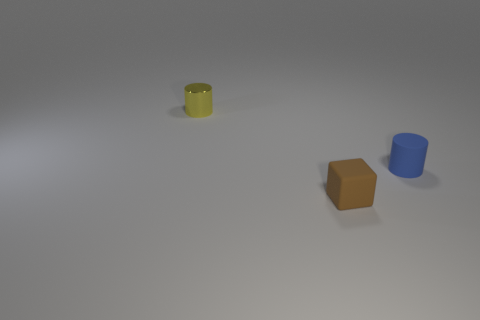Add 1 small blue shiny balls. How many objects exist? 4 Subtract all cubes. How many objects are left? 2 Add 3 purple balls. How many purple balls exist? 3 Subtract 0 green cylinders. How many objects are left? 3 Subtract all small blue matte things. Subtract all small blue things. How many objects are left? 1 Add 3 tiny brown blocks. How many tiny brown blocks are left? 4 